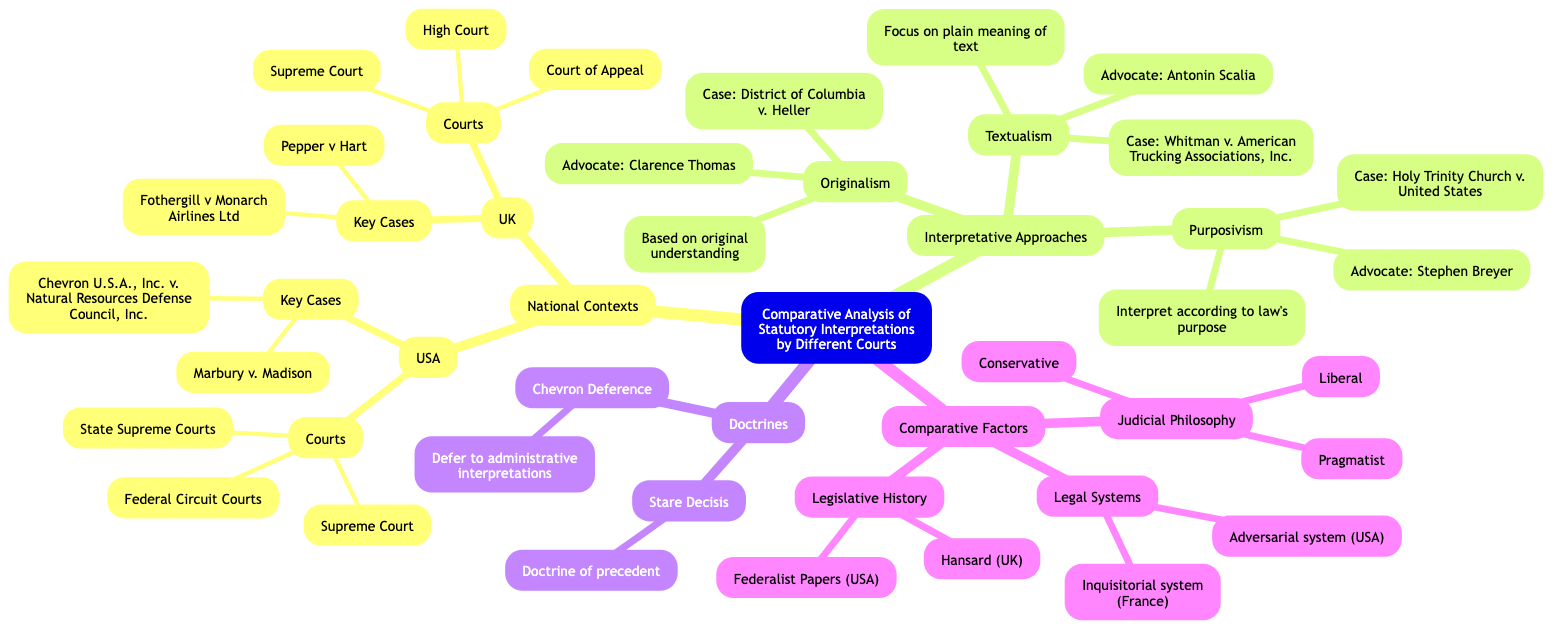What is the first court listed under the USA national context? The diagram indicates that under the "USA" national context, "Supreme Court" is the first court listed.
Answer: Supreme Court How many key cases are listed under the UK context? In the UK context, there are two key cases mentioned: "Pepper v Hart" and "Fothergill v Monarch Airlines Ltd." This counts for a total of two cases.
Answer: 2 Who is the prominent advocate of Purposivism? The diagram explicitly states that "Stephen Breyer" is the prominent advocate of Purposivism.
Answer: Stephen Breyer What doctrine is defined by the principle of deferring to administrative interpretations? The diagram shows that "Chevron Deference" describes the principle where courts defer to administrative interpretations of ambiguous statutes.
Answer: Chevron Deference What examples are provided for Judicial Philosophy? The diagram lists three philosophies as examples under "Judicial Philosophy": "Conservative," "Liberal," and "Pragmatist."
Answer: Conservative, Liberal, Pragmatist Which interpretative approach focuses on the plain meaning of the statutory text? According to the diagram, the interpretative approach that focuses on plain meaning is "Textualism."
Answer: Textualism Which case is associated with the doctrine of Stare Decisis? The diagram does not associate any specific case with "Stare Decisis," as it only describes the doctrine itself. So, there is no case mentioned.
Answer: None How many courts are mentioned under the UK context? In the UK national context, three courts are enumerated: "Supreme Court," "Court of Appeal," and "High Court," totaling three courts.
Answer: 3 What is the primary focus of Originalism as an interpretative approach? The diagram states that Originalism is centered on "Interpretation based on the original understanding at the time of the law’s enactment."
Answer: Based on original understanding 